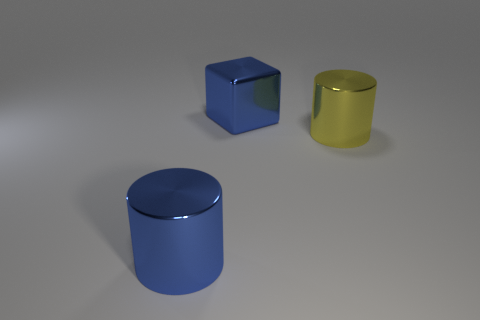Do the yellow metal object and the big blue metallic thing in front of the big shiny cube have the same shape?
Your answer should be very brief. Yes. There is a metallic cylinder that is in front of the big cylinder on the right side of the big cube; how many big blue things are behind it?
Provide a succinct answer. 1. The other metal thing that is the same shape as the yellow thing is what color?
Your answer should be very brief. Blue. Is there anything else that has the same shape as the large yellow metallic thing?
Offer a very short reply. Yes. What number of blocks are either big objects or big yellow objects?
Provide a short and direct response. 1. What shape is the yellow shiny thing?
Your answer should be very brief. Cylinder. There is a shiny block; are there any big cylinders to the left of it?
Your answer should be very brief. Yes. Is the material of the large cube the same as the cylinder that is to the right of the blue cylinder?
Keep it short and to the point. Yes. Do the large blue object on the left side of the big metal cube and the yellow shiny thing have the same shape?
Ensure brevity in your answer.  Yes. What number of large yellow things are the same material as the big blue cube?
Offer a terse response. 1. 